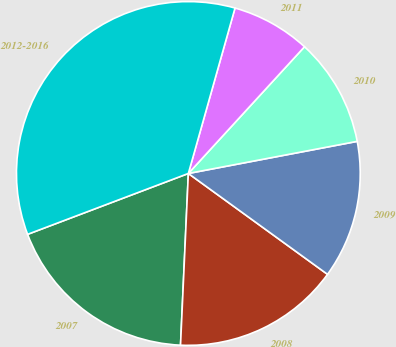Convert chart to OTSL. <chart><loc_0><loc_0><loc_500><loc_500><pie_chart><fcel>2007<fcel>2008<fcel>2009<fcel>2010<fcel>2011<fcel>2012-2016<nl><fcel>18.51%<fcel>15.74%<fcel>12.97%<fcel>10.2%<fcel>7.43%<fcel>35.13%<nl></chart> 